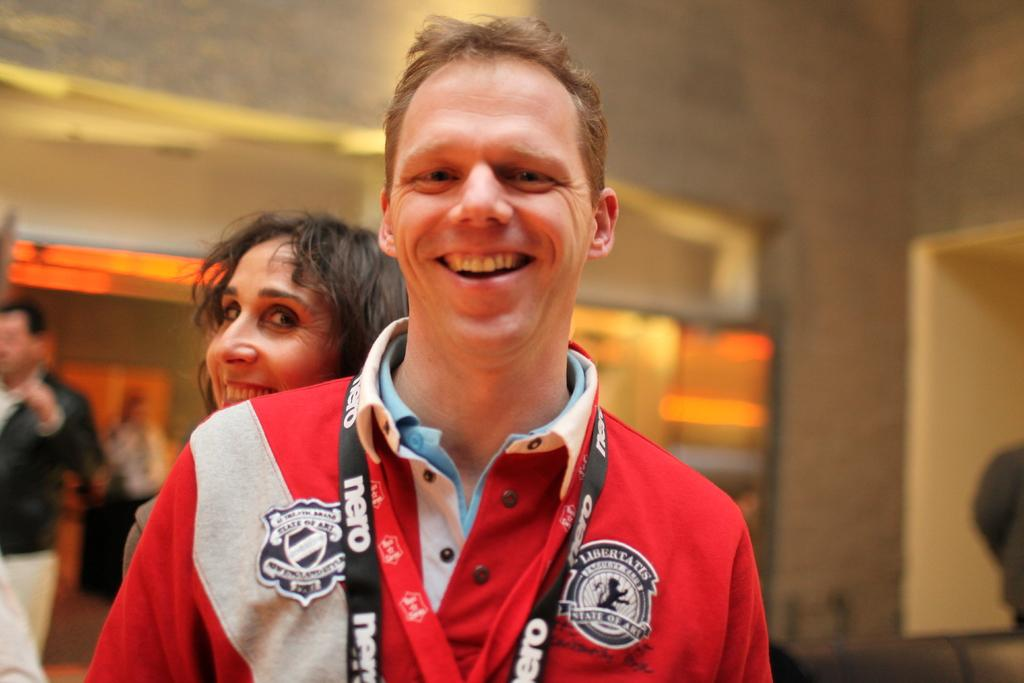Who is the main subject in the image? There is a man in the image. What is the man wearing? The man is wearing a red jacket. Can you describe the woman in the image? There is a woman standing behind the man. Who else is present in the image? There is another man on the left side of the image. What can be seen in the background of the image? There is a wall and lights visible in the background. How many mice are crawling on the man's red jacket in the image? There are no mice present in the image; the man is wearing a red jacket. What rule is being enforced by the man in the image? There is no indication of any rule being enforced in the image. 